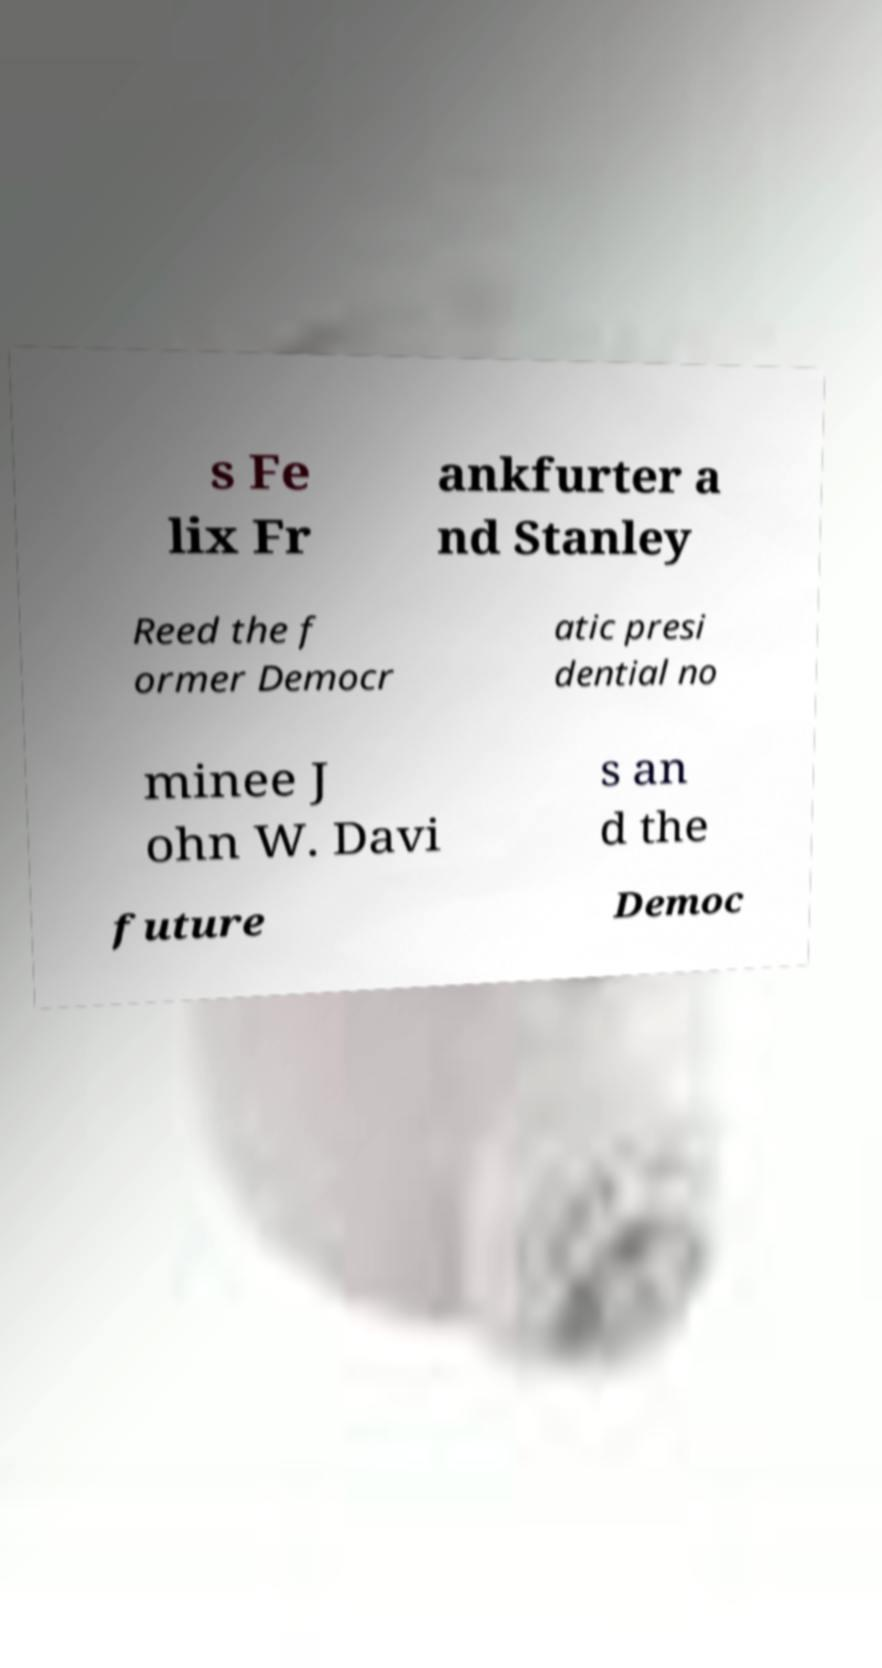Can you accurately transcribe the text from the provided image for me? s Fe lix Fr ankfurter a nd Stanley Reed the f ormer Democr atic presi dential no minee J ohn W. Davi s an d the future Democ 